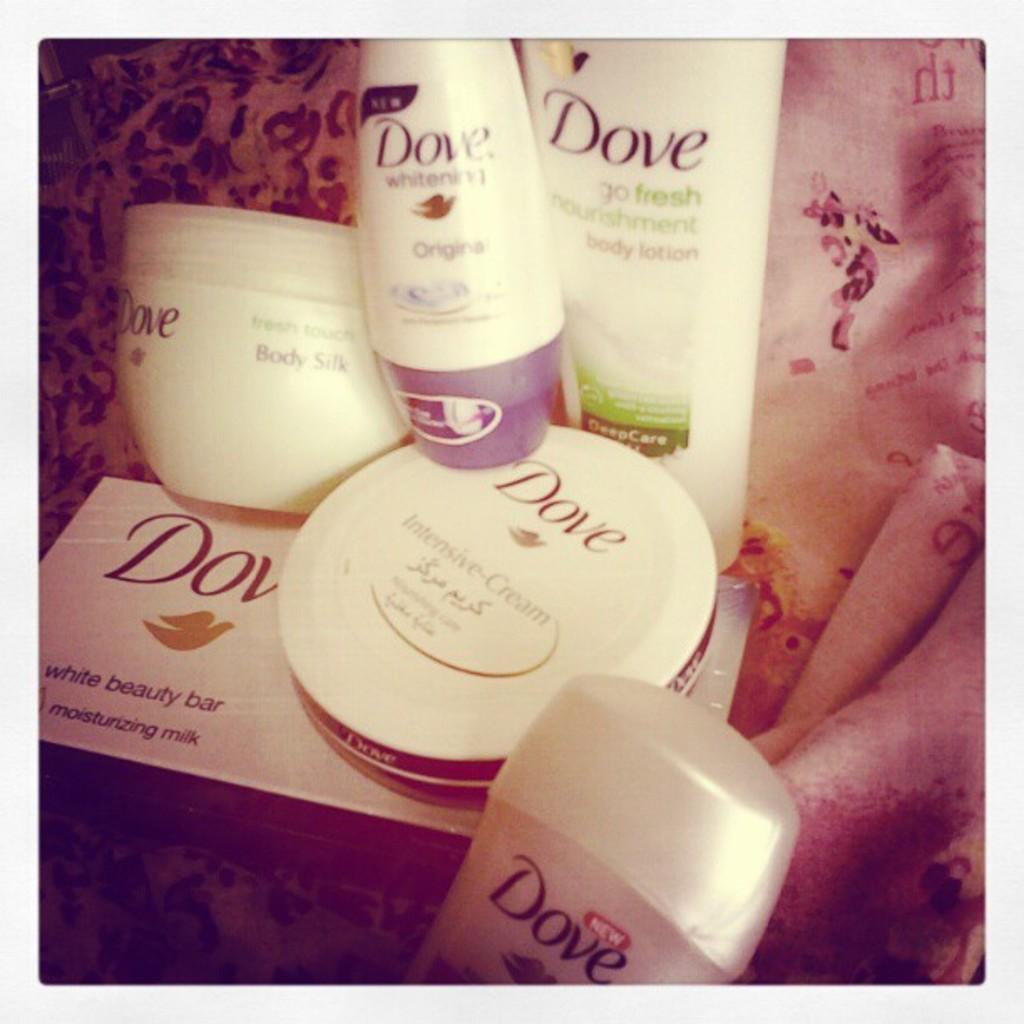How would you summarize this image in a sentence or two? In the image there are bottles and boxes with names and logos. Behind them there is cloth. 